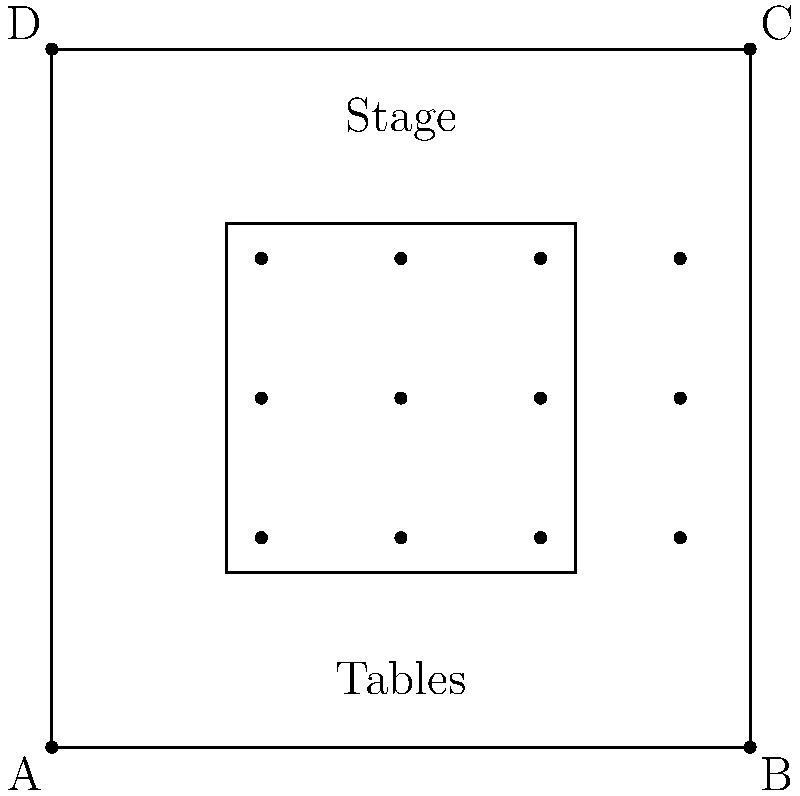As a wedding singer, you're often consulted on seating arrangements. In the diagram above, which represents a square reception hall with a central dance floor, how many guests can be seated if each dot represents a table that seats 8 people? To determine the number of guests that can be seated, we need to follow these steps:

1. Count the number of dots (tables) in the diagram:
   There are 4 rows, each containing 3 dots.
   Total number of tables = 4 × 3 = 12 tables

2. Calculate the number of guests per table:
   Each dot represents a table that seats 8 people.

3. Calculate the total number of guests:
   Total guests = Number of tables × Guests per table
   Total guests = 12 × 8 = 96 guests

Therefore, the seating arrangement in this square reception hall with a central dance floor can accommodate 96 guests.
Answer: 96 guests 